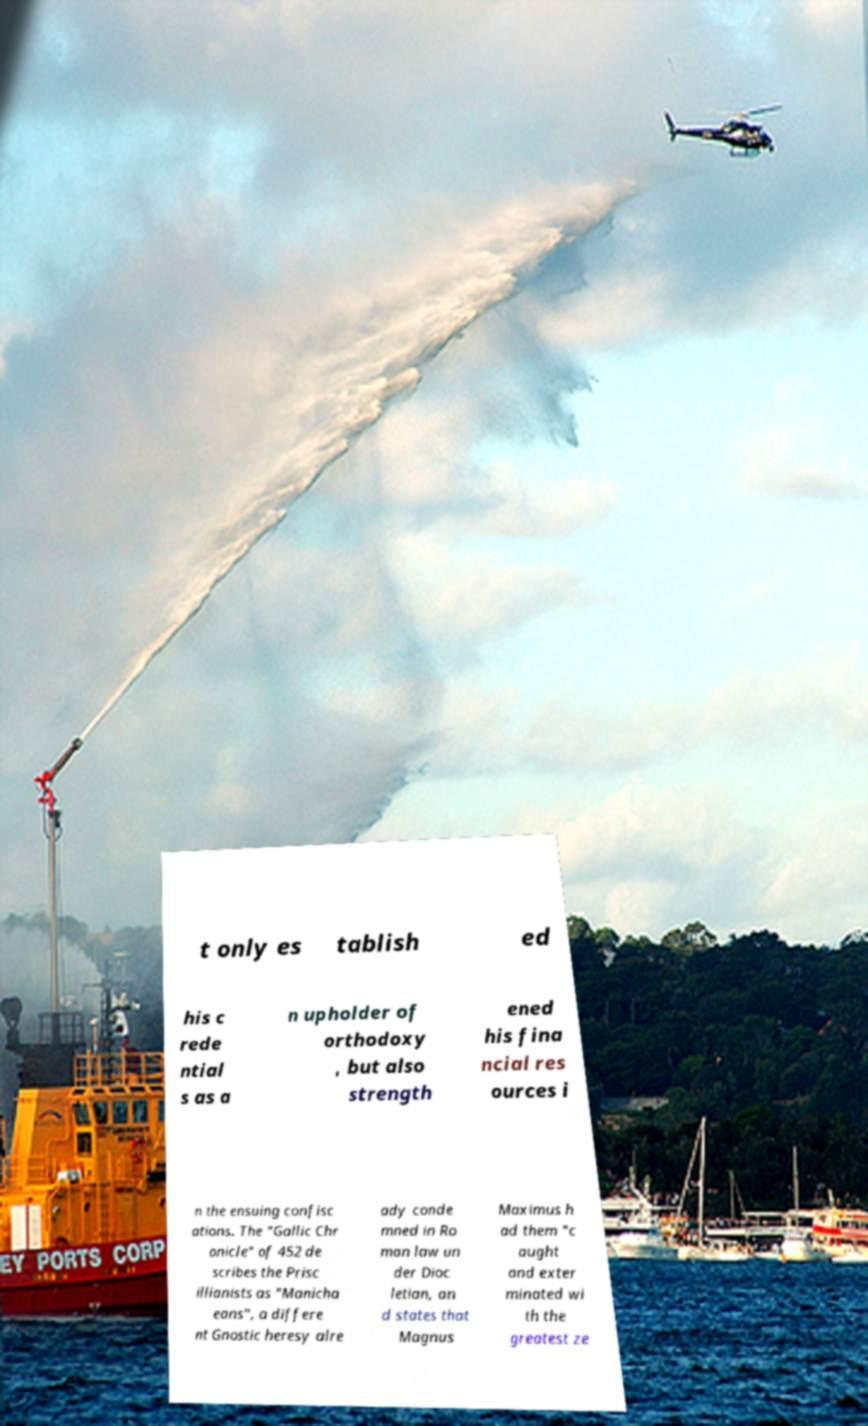Can you accurately transcribe the text from the provided image for me? t only es tablish ed his c rede ntial s as a n upholder of orthodoxy , but also strength ened his fina ncial res ources i n the ensuing confisc ations. The "Gallic Chr onicle" of 452 de scribes the Prisc illianists as "Manicha eans", a differe nt Gnostic heresy alre ady conde mned in Ro man law un der Dioc letian, an d states that Magnus Maximus h ad them "c aught and exter minated wi th the greatest ze 